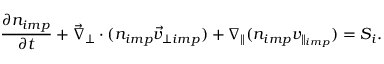Convert formula to latex. <formula><loc_0><loc_0><loc_500><loc_500>\frac { \partial n _ { i m p } } { \partial t } + \vec { \nabla } _ { \perp } \cdot ( n _ { i m p } \vec { v } _ { \perp i m p } ) + \nabla _ { \| } ( n _ { i m p } v _ { \| _ { i m p } } ) = S _ { i } .</formula> 